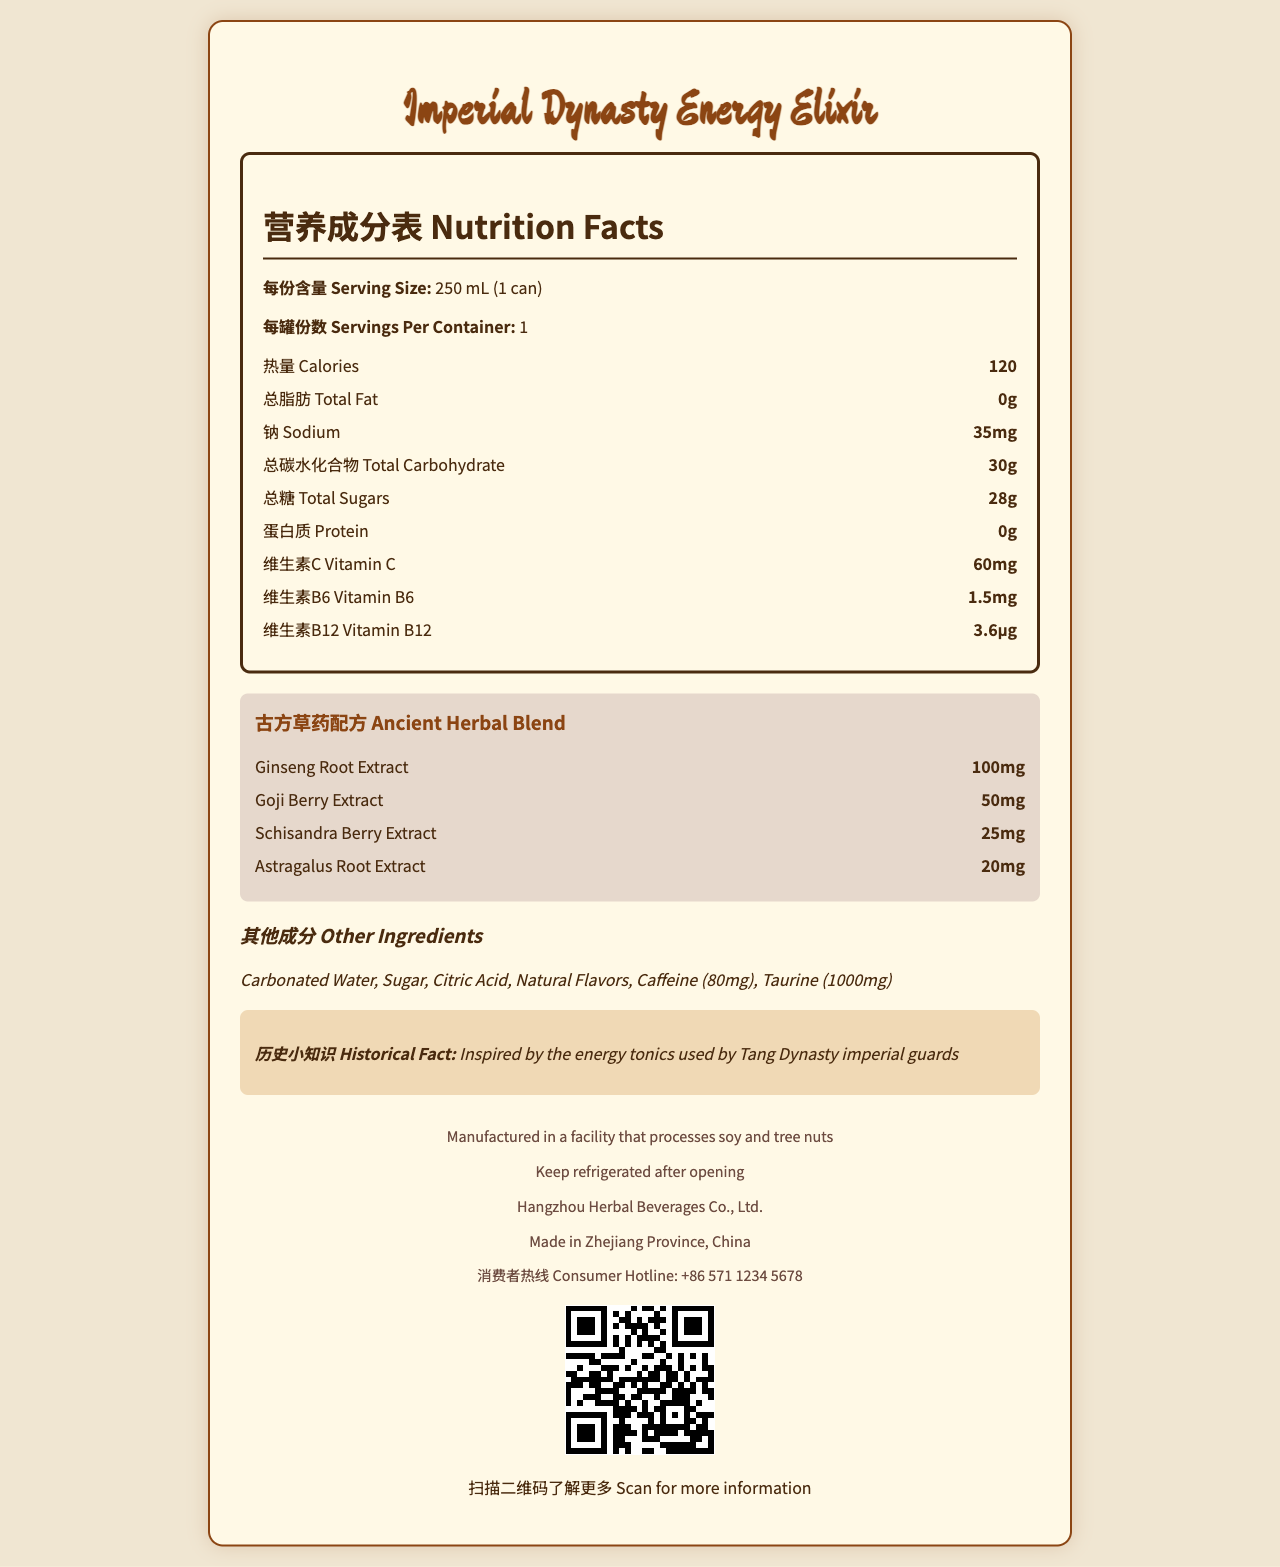What is the serving size of the Imperial Dynasty Energy Elixir? The serving size is listed as 250 mL (1 can) in the document.
Answer: 250 mL (1 can) How many calories are in one can of Imperial Dynasty Energy Elixir? The document specifies that there are 120 calories in one can of the drink.
Answer: 120 How much total sugar is in one serving of Imperial Dynasty Energy Elixir? The document lists the total sugars as 28 grams.
Answer: 28g Which ancient herbal ingredient in the Imperial Dynasty Energy Elixir has the highest amount? The document lists Ginseng Root Extract as having the highest amount at 100mg.
Answer: Ginseng Root Extract How much Vitamin C does the Imperial Dynasty Energy Elixir contain? The document specifies that the elixir contains 60mg of Vitamin C.
Answer: 60mg Which of the following is not an ingredient in the Imperial Dynasty Energy Elixir? A) Carbonated Water B) Citric Acid C) Corn Syrup D) Caffeine The document does not list Corn Syrup as an ingredient; it lists Carbonated Water, Citric Acid, and Caffeine.
Answer: C) Corn Syrup Where is the Imperial Dynasty Energy Elixir manufactured? A) Guangzhou B) Beijing C) Zhejiang Province D) Shanghai The document states that the elixir is made in Zhejiang Province, China.
Answer: C) Zhejiang Province How much Caffeine is present in the Imperial Dynasty Energy Elixir? A) 80mg B) 100mg C) 50mg D) 20mg The document lists 80mg of Caffeine in the elixir.
Answer: A) 80mg Is there any protein in the Imperial Dynasty Energy Elixir? The document specifies that the protein content is 0 grams.
Answer: No Does the Imperial Dynasty Energy Elixir contain any allergens? The document mentions that it is manufactured in a facility that processes soy and tree nuts.
Answer: Yes Summarize the main nutritional components and unique features of the Imperial Dynasty Energy Elixir. The document details various nutritional components along with ancient herbal ingredients and other notable features like manufacturing origin and historical inspiration.
Answer: The Imperial Dynasty Energy Elixir is an energy drink with 120 calories per can, 0g total fat, 35mg sodium, 30g total carbohydrates, 28g total sugars, and 0g protein. It includes vitamins like Vitamin C (60mg), Vitamin B6 (1.5mg), and Vitamin B12 (3.6μg). It features an ancient herbal blend with ingredients such as Ginseng Root Extract (100mg), Goji Berry Extract (50mg), Schisandra Berry Extract (25mg), and Astragalus Root Extract (20mg), along with other ingredients like Carbonated Water, Sugar, Citric Acid, Natural Flavors, Caffeine, and Taurine. The drink is manufactured by Hangzhou Herbal Beverages Co., Ltd. in Zhejiang Province, China, and is inspired by the energy tonics used by Tang Dynasty imperial guards. When was the Imperial Dynasty Energy Elixir first introduced? The document does not provide any information regarding the introduction date of the elixir.
Answer: Cannot be determined 